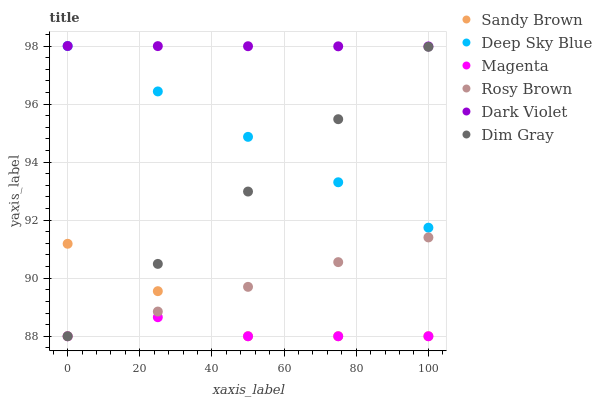Does Magenta have the minimum area under the curve?
Answer yes or no. Yes. Does Dark Violet have the maximum area under the curve?
Answer yes or no. Yes. Does Rosy Brown have the minimum area under the curve?
Answer yes or no. No. Does Rosy Brown have the maximum area under the curve?
Answer yes or no. No. Is Rosy Brown the smoothest?
Answer yes or no. Yes. Is Magenta the roughest?
Answer yes or no. Yes. Is Dark Violet the smoothest?
Answer yes or no. No. Is Dark Violet the roughest?
Answer yes or no. No. Does Dim Gray have the lowest value?
Answer yes or no. Yes. Does Dark Violet have the lowest value?
Answer yes or no. No. Does Deep Sky Blue have the highest value?
Answer yes or no. Yes. Does Rosy Brown have the highest value?
Answer yes or no. No. Is Dim Gray less than Dark Violet?
Answer yes or no. Yes. Is Dark Violet greater than Magenta?
Answer yes or no. Yes. Does Dim Gray intersect Rosy Brown?
Answer yes or no. Yes. Is Dim Gray less than Rosy Brown?
Answer yes or no. No. Is Dim Gray greater than Rosy Brown?
Answer yes or no. No. Does Dim Gray intersect Dark Violet?
Answer yes or no. No. 